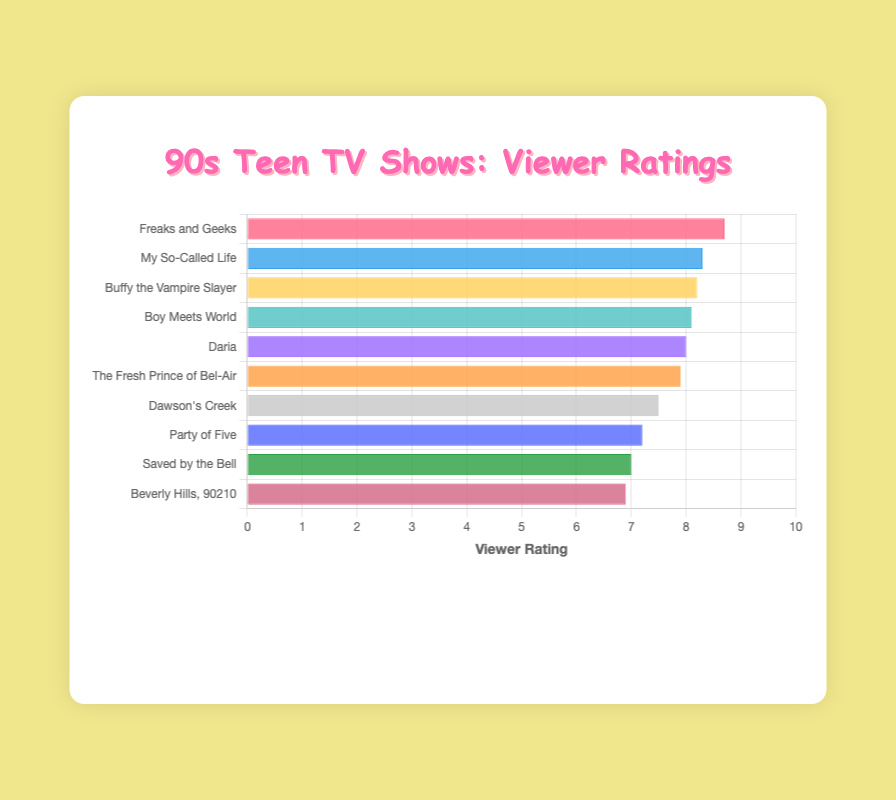Which TV show has the highest viewer rating? Look at the bars and their lengths in the chart. The longest bar represents the highest rating. "Freaks and Geeks" has the longest bar with a rating of 8.7.
Answer: Freaks and Geeks Which TV show has the lowest viewer rating? Examine the shortest bar in the chart. The shortest bar is for "Beverly Hills, 90210" with a rating of 6.9.
Answer: Beverly Hills, 90210 What is the difference in ratings between the highest-rated and lowest-rated TV shows? The highest rating is 8.7 ("Freaks and Geeks") and the lowest is 6.9 ("Beverly Hills, 90210"). The difference is calculated by subtracting the lowest rating from the highest: 8.7 - 6.9 = 1.8.
Answer: 1.8 What is the average rating of all the TV shows? Sum all the ratings: 8.7 + 8.3 + 8.2 + 8.1 + 8.0 + 7.9 + 7.5 + 7.2 + 7.0 + 6.9 = 77.8. Then divide by the number of shows: 77.8 / 10 = 7.78.
Answer: 7.78 How many TV shows have a rating of 8.0 or higher? Count the number of bars with ratings 8.0 or above. These are for "Freaks and Geeks," "My So-Called Life," "Buffy the Vampire Slayer," "Boy Meets World," and "Daria," totaling 5 shows.
Answer: 5 Which TV show has a slightly lower rating than "Boy Meets World"? Look for the bar just below "Boy Meets World" which has a rating of 8.1. The slightly lower rating is 8.0 for "Daria."
Answer: Daria Which TV show rating is closer to the median of all ratings? List the ratings in ascending order (6.9, 7.0, 7.2, 7.5, 7.9, 8.0, 8.1, 8.2, 8.3, 8.7). The median is (7.9+8.0)/2 = 7.95. The rating closest to 7.95 is "Daria" with 8.0.
Answer: Daria What is the combined rating of "Daria" and "The Fresh Prince of Bel-Air"? Add their ratings together: 8.0 ("Daria") + 7.9 ("The Fresh Prince of Bel-Air") = 15.9.
Answer: 15.9 How many shows have a rating below 7.5? Identify the bars for ratings below 7.5. These are "Saved by the Bell," "Beverly Hills, 90210," and "Party of Five." There are 3 shows.
Answer: 3 